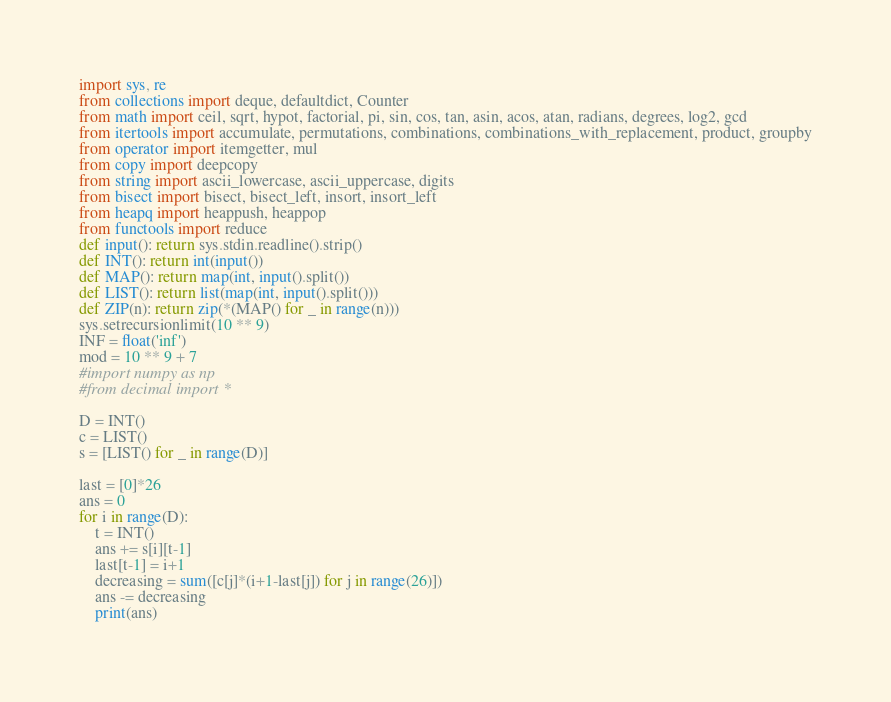Convert code to text. <code><loc_0><loc_0><loc_500><loc_500><_Python_>import sys, re
from collections import deque, defaultdict, Counter
from math import ceil, sqrt, hypot, factorial, pi, sin, cos, tan, asin, acos, atan, radians, degrees, log2, gcd
from itertools import accumulate, permutations, combinations, combinations_with_replacement, product, groupby
from operator import itemgetter, mul
from copy import deepcopy
from string import ascii_lowercase, ascii_uppercase, digits
from bisect import bisect, bisect_left, insort, insort_left
from heapq import heappush, heappop
from functools import reduce
def input(): return sys.stdin.readline().strip()
def INT(): return int(input())
def MAP(): return map(int, input().split())
def LIST(): return list(map(int, input().split()))
def ZIP(n): return zip(*(MAP() for _ in range(n)))
sys.setrecursionlimit(10 ** 9)
INF = float('inf')
mod = 10 ** 9 + 7
#import numpy as np
#from decimal import *

D = INT()
c = LIST()
s = [LIST() for _ in range(D)]

last = [0]*26
ans = 0
for i in range(D):
	t = INT()
	ans += s[i][t-1]
	last[t-1] = i+1
	decreasing = sum([c[j]*(i+1-last[j]) for j in range(26)])
	ans -= decreasing
	print(ans)
</code> 